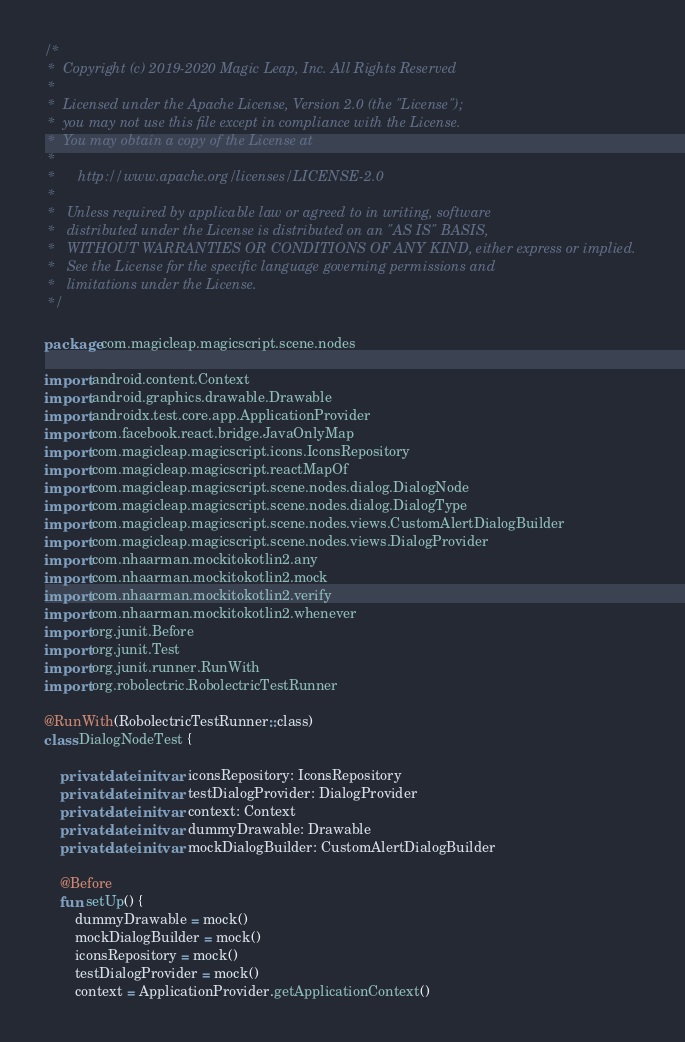Convert code to text. <code><loc_0><loc_0><loc_500><loc_500><_Kotlin_>/*
 *  Copyright (c) 2019-2020 Magic Leap, Inc. All Rights Reserved
 *
 *  Licensed under the Apache License, Version 2.0 (the "License");
 *  you may not use this file except in compliance with the License.
 *  You may obtain a copy of the License at
 *
 *      http://www.apache.org/licenses/LICENSE-2.0
 *
 *   Unless required by applicable law or agreed to in writing, software
 *   distributed under the License is distributed on an "AS IS" BASIS,
 *   WITHOUT WARRANTIES OR CONDITIONS OF ANY KIND, either express or implied.
 *   See the License for the specific language governing permissions and
 *   limitations under the License.
 */

package com.magicleap.magicscript.scene.nodes

import android.content.Context
import android.graphics.drawable.Drawable
import androidx.test.core.app.ApplicationProvider
import com.facebook.react.bridge.JavaOnlyMap
import com.magicleap.magicscript.icons.IconsRepository
import com.magicleap.magicscript.reactMapOf
import com.magicleap.magicscript.scene.nodes.dialog.DialogNode
import com.magicleap.magicscript.scene.nodes.dialog.DialogType
import com.magicleap.magicscript.scene.nodes.views.CustomAlertDialogBuilder
import com.magicleap.magicscript.scene.nodes.views.DialogProvider
import com.nhaarman.mockitokotlin2.any
import com.nhaarman.mockitokotlin2.mock
import com.nhaarman.mockitokotlin2.verify
import com.nhaarman.mockitokotlin2.whenever
import org.junit.Before
import org.junit.Test
import org.junit.runner.RunWith
import org.robolectric.RobolectricTestRunner

@RunWith(RobolectricTestRunner::class)
class DialogNodeTest {

    private lateinit var iconsRepository: IconsRepository
    private lateinit var testDialogProvider: DialogProvider
    private lateinit var context: Context
    private lateinit var dummyDrawable: Drawable
    private lateinit var mockDialogBuilder: CustomAlertDialogBuilder

    @Before
    fun setUp() {
        dummyDrawable = mock()
        mockDialogBuilder = mock()
        iconsRepository = mock()
        testDialogProvider = mock()
        context = ApplicationProvider.getApplicationContext()</code> 